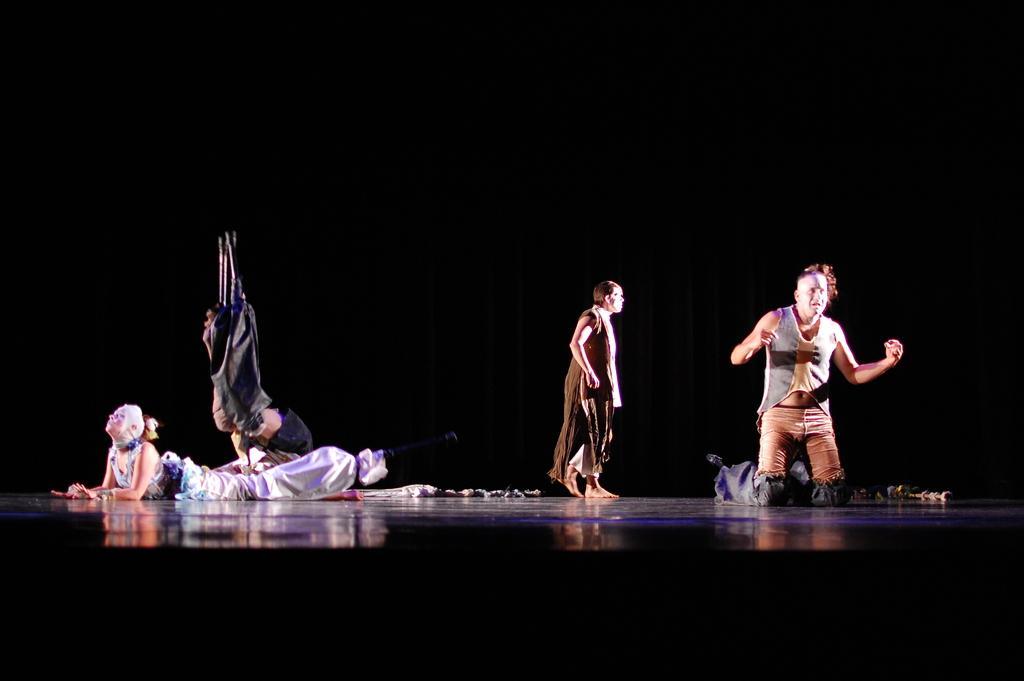Could you give a brief overview of what you see in this image? In this picture there are people, among them one person walking and one person lying on the floor and we can see objects. In the background of the image it is dark. 